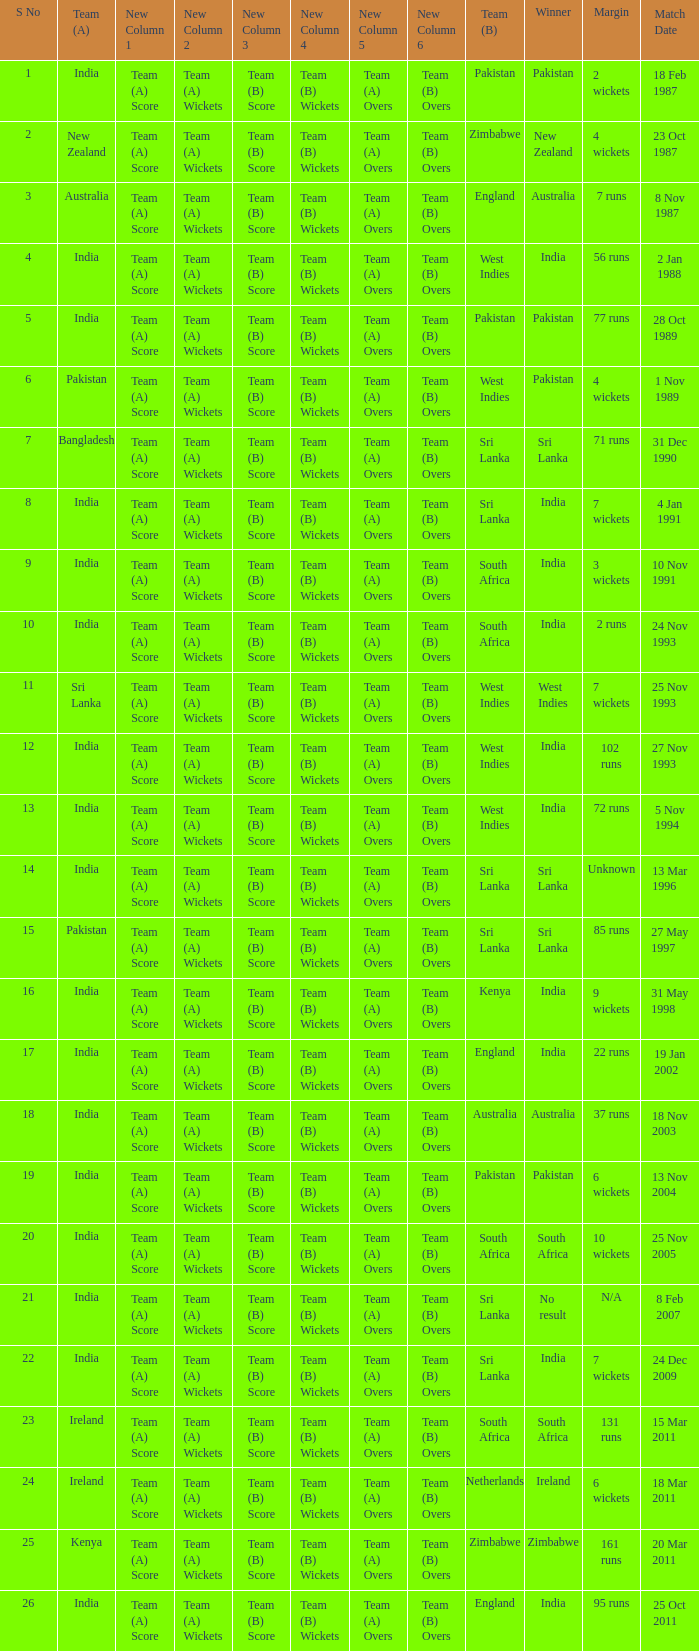How many games were won by a margin of 131 runs? 1.0. 